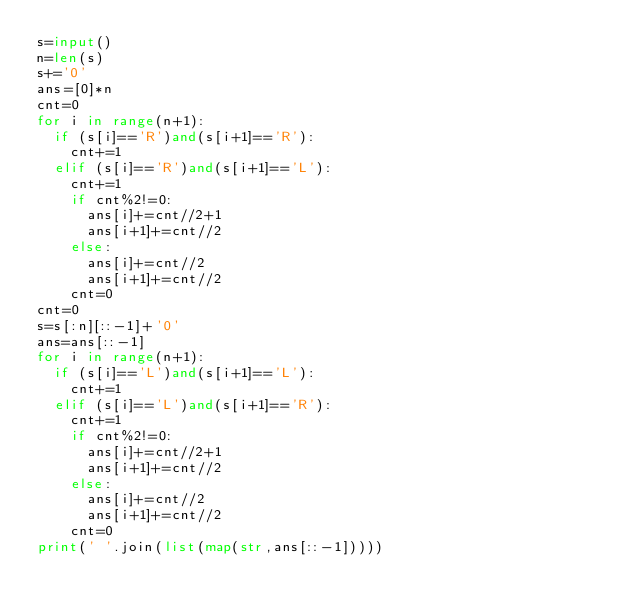Convert code to text. <code><loc_0><loc_0><loc_500><loc_500><_Python_>s=input()
n=len(s)
s+='0'
ans=[0]*n
cnt=0
for i in range(n+1):
  if (s[i]=='R')and(s[i+1]=='R'):
    cnt+=1
  elif (s[i]=='R')and(s[i+1]=='L'):
    cnt+=1
    if cnt%2!=0:
      ans[i]+=cnt//2+1
      ans[i+1]+=cnt//2
    else:
      ans[i]+=cnt//2
      ans[i+1]+=cnt//2
    cnt=0
cnt=0
s=s[:n][::-1]+'0'
ans=ans[::-1]
for i in range(n+1):
  if (s[i]=='L')and(s[i+1]=='L'):
    cnt+=1
  elif (s[i]=='L')and(s[i+1]=='R'):
    cnt+=1
    if cnt%2!=0:
      ans[i]+=cnt//2+1
      ans[i+1]+=cnt//2
    else:
      ans[i]+=cnt//2
      ans[i+1]+=cnt//2
    cnt=0
print(' '.join(list(map(str,ans[::-1]))))</code> 